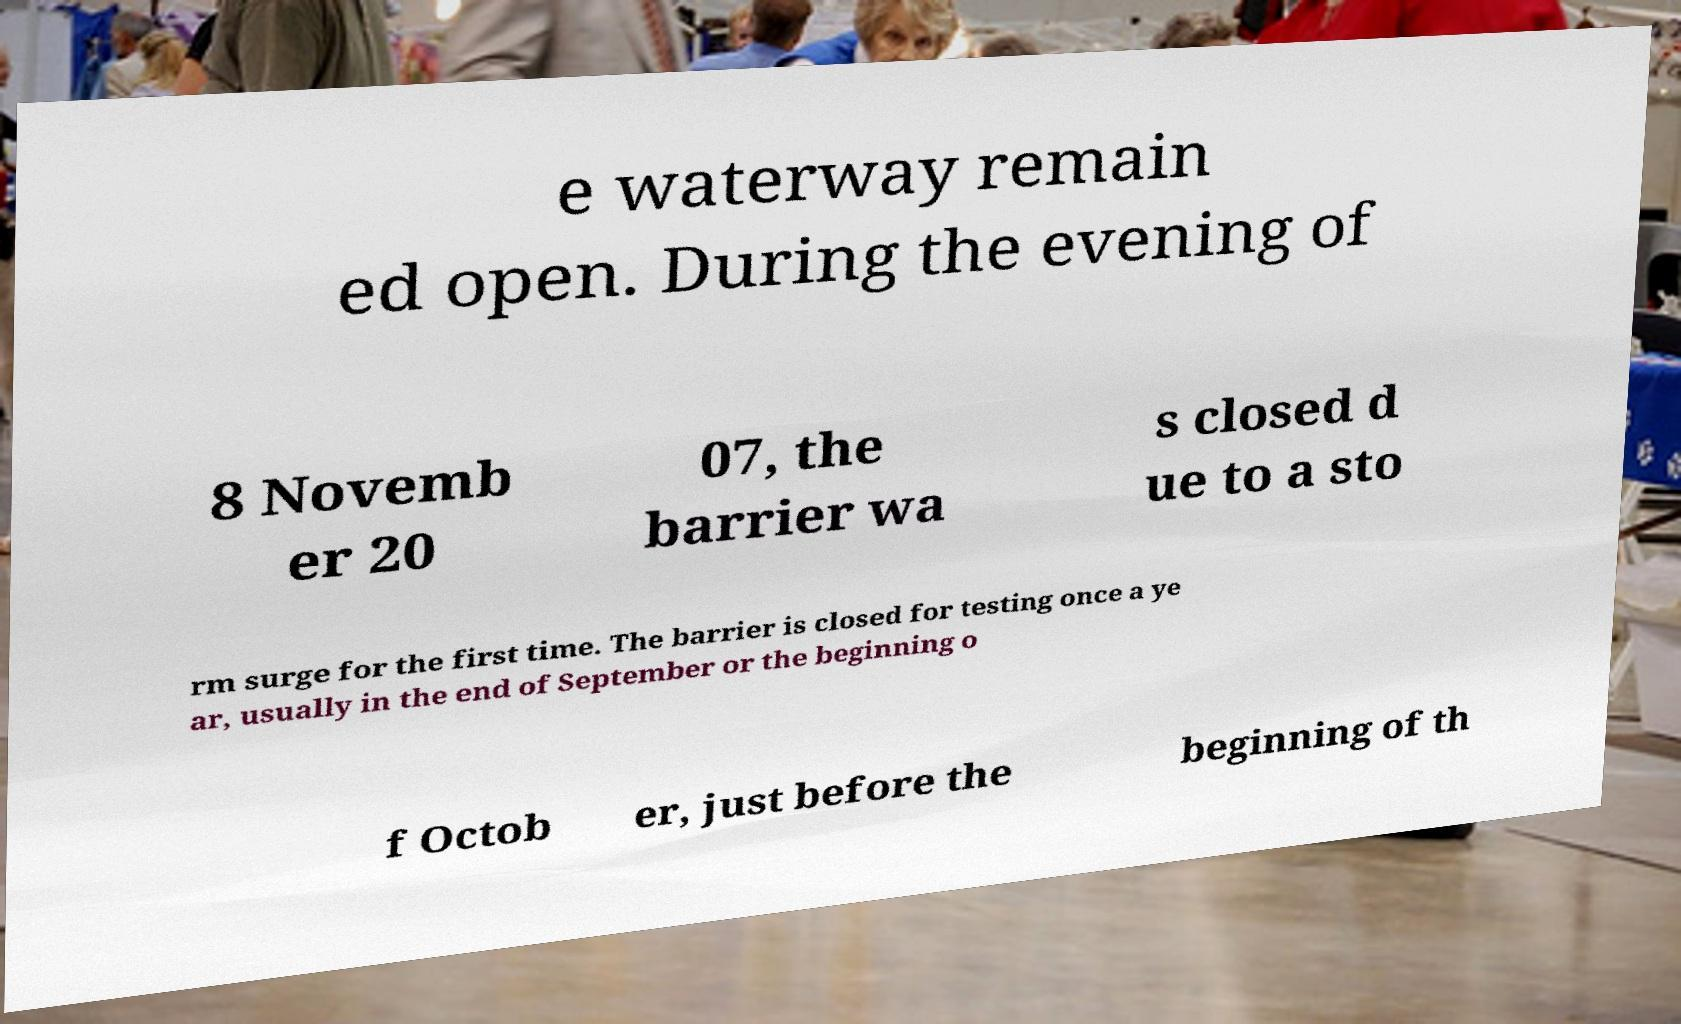There's text embedded in this image that I need extracted. Can you transcribe it verbatim? e waterway remain ed open. During the evening of 8 Novemb er 20 07, the barrier wa s closed d ue to a sto rm surge for the first time. The barrier is closed for testing once a ye ar, usually in the end of September or the beginning o f Octob er, just before the beginning of th 